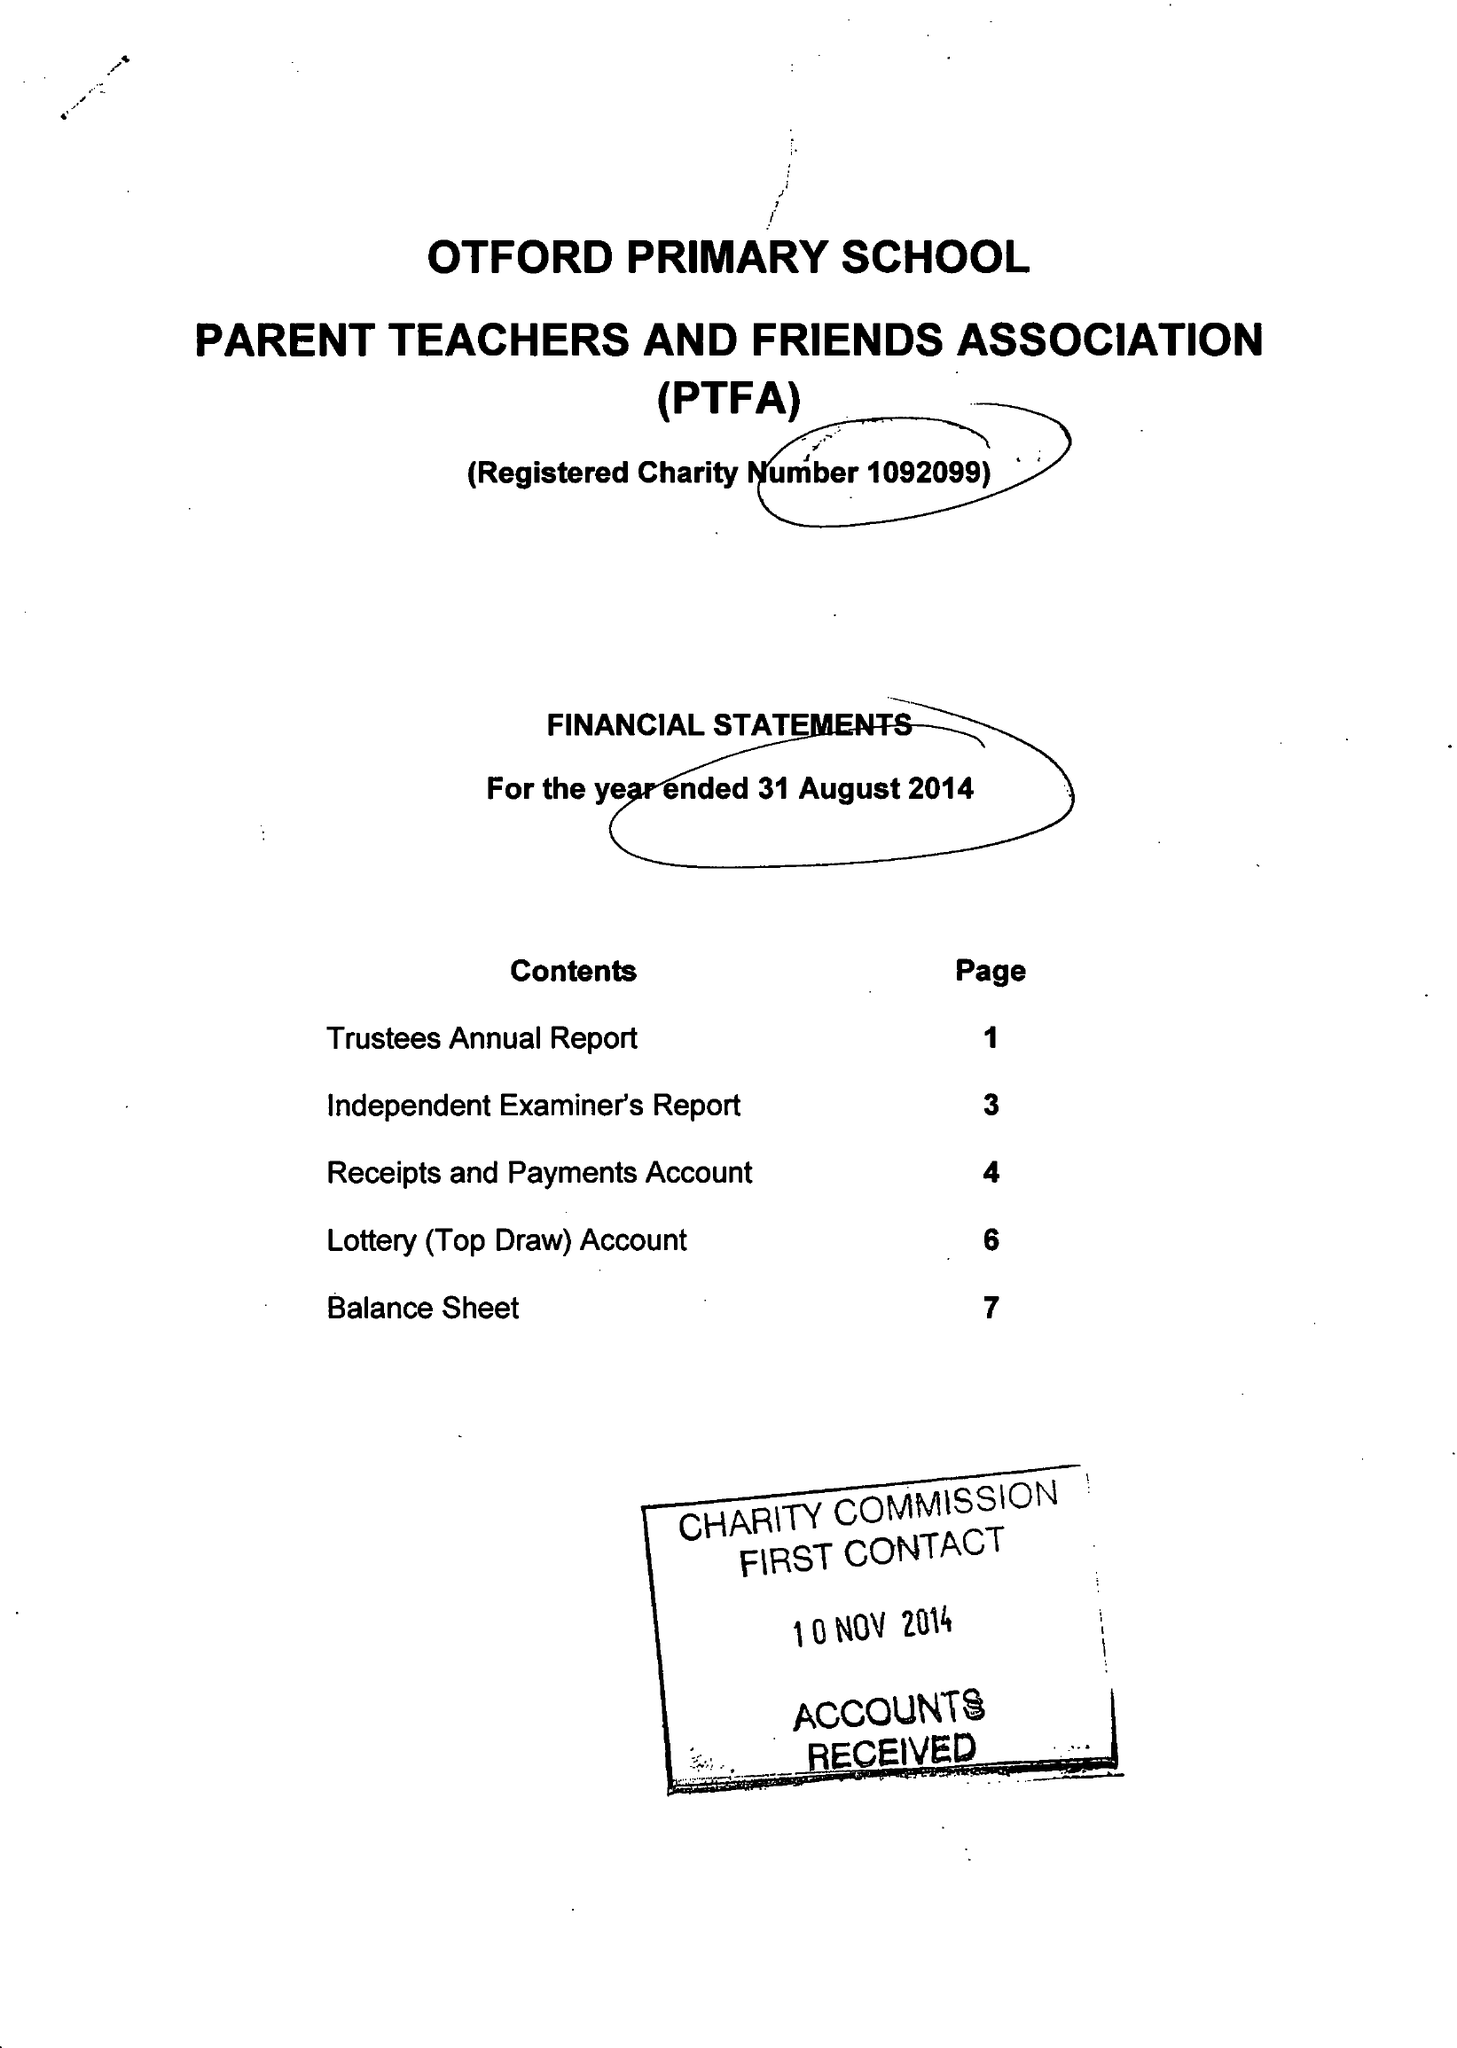What is the value for the address__post_town?
Answer the question using a single word or phrase. SEVENOAKS 